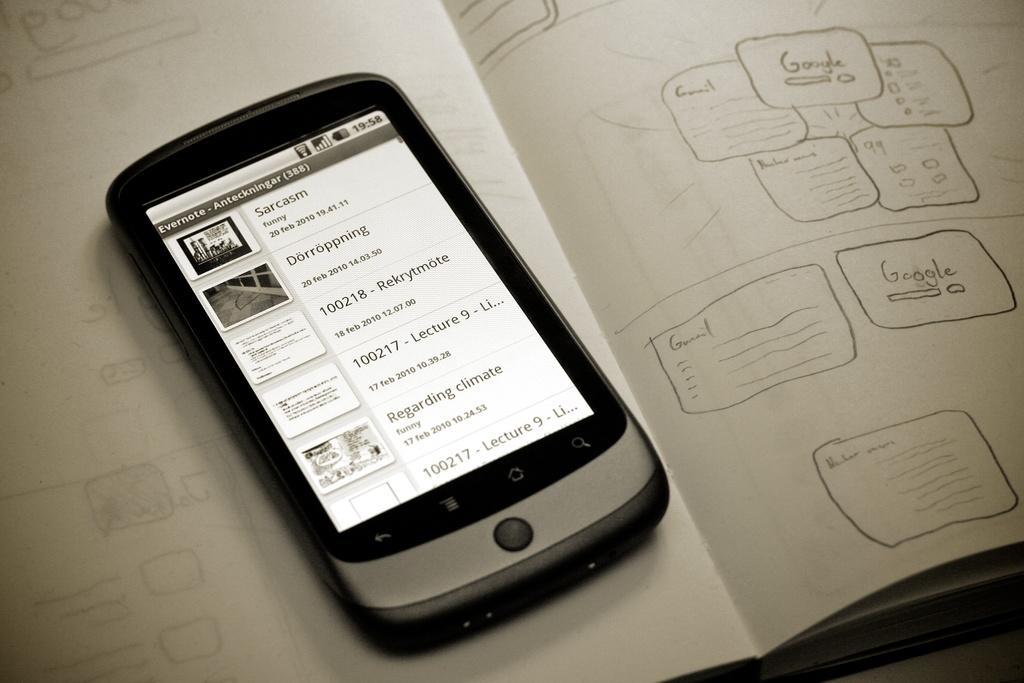<image>
Share a concise interpretation of the image provided. An Evernote screen with a list showing Sarcasm, Regarding climate change, and lectures 8 and 9. 